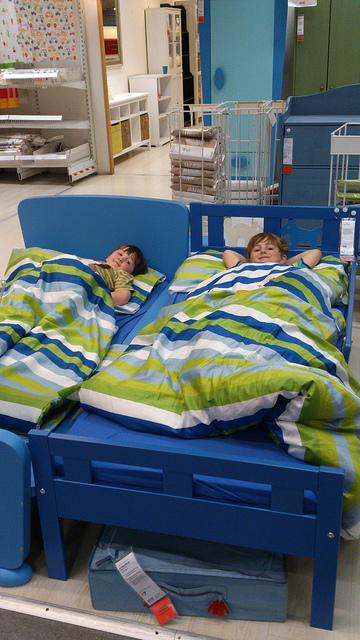Where are the beds that the boys are lying on?

Choices:
A) living room
B) bedroom
C) daycare
D) furniture store furniture store 